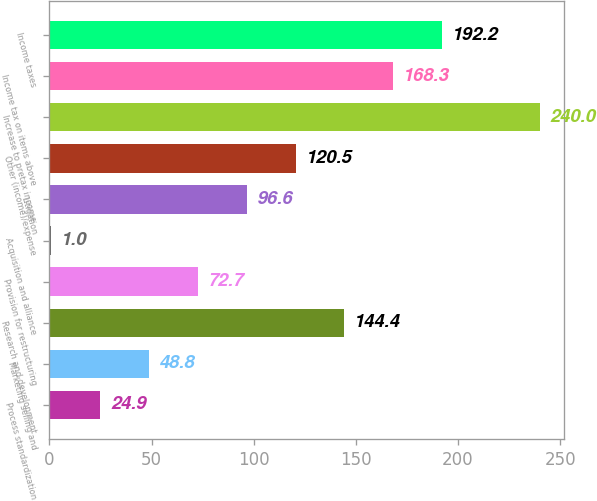<chart> <loc_0><loc_0><loc_500><loc_500><bar_chart><fcel>Process standardization<fcel>Marketing selling and<fcel>Research and development<fcel>Provision for restructuring<fcel>Acquisition and alliance<fcel>Litigation<fcel>Other (income)/expense<fcel>Increase to pretax income<fcel>Income tax on items above<fcel>Income taxes<nl><fcel>24.9<fcel>48.8<fcel>144.4<fcel>72.7<fcel>1<fcel>96.6<fcel>120.5<fcel>240<fcel>168.3<fcel>192.2<nl></chart> 